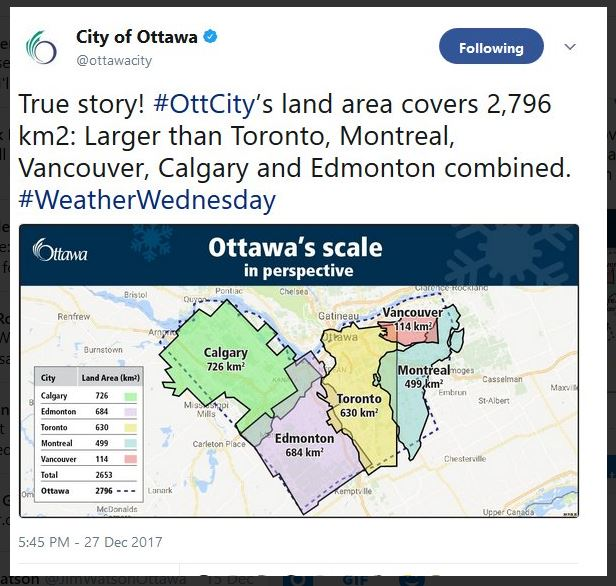In a brief statement, why is having a larger land area than these other cities significant for Ottawa? Having a larger land area than these other cities allows Ottawa to offer more diverse land use possibilities, support extensive green spaces and infrastructural expansion, and potentially enjoy lower population density with more room for growth and development. 